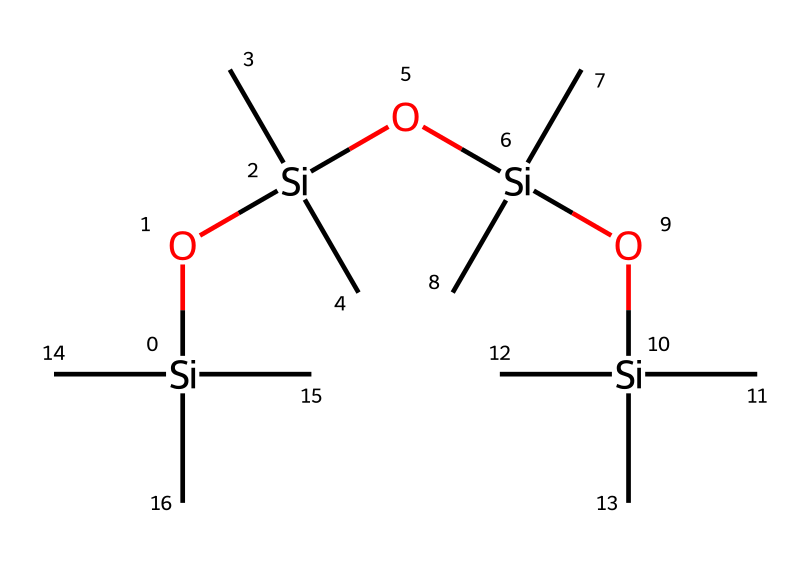How many silicon atoms are present in this structure? The given SMILES representation shows that there are four silicon atoms ([Si]) connected with oxygen and carbon groups. Counting each occurrence of [Si] confirms there are four.
Answer: four What type of chemical bonds are predominantly present in this structure? Analyzing the SMILES notation, the structure mainly consists of silicon-oxygen (Si-O) and silicon-carbon (Si-C) bonds. The presence of silicon at the core with oxygen and carbon groups indicates these bond types.
Answer: Si-O, Si-C What is the degree of branching in the chemical structure? The structure shows a high degree of branching due to the presence of multiple carbon groups (C) connected to each silicon atom. Each silicon atom is bonded to several carbon (C) atoms, contributing to the branched nature.
Answer: high What functional groups are identified in this silicone structure? Examining the structure reveals hydroxyl groups (Si-OH) as functional groups due to -O connections to silicon. Each silicon is bonded to an -OH group, which is typical in silicone compounds.
Answer: hydroxyl How many carbon groups are attached to the central silicon? Each silicon atom in the structure has three carbon groups attached, and with four silicon atoms present, total carbon groups can be calculated. Specifically, it is three carbon groups for each of the four silicon atoms, resulting in twelve carbon groups altogether.
Answer: twelve Why is this compound suitable for anti-fogging purposes? The silicone-based structure provides surface tension reduction due to its hydrophobic properties, preventing water from forming fog on surfaces like train windows. The arrangement of silicon and oxygen creates a film that resists moisture accumulation.
Answer: hydrophobic What role do the oxygen atoms play in the structure? The oxygen atoms serve as bridge groups linking silicon atoms, facilitating the formation of a flexible network. This connectivity contributes to the overall stability and effectiveness of the compound, especially in anti-fogging scenarios.
Answer: bridging 